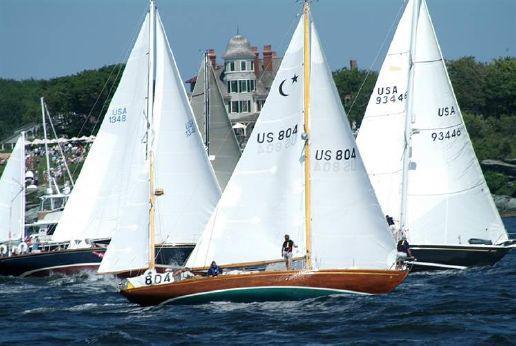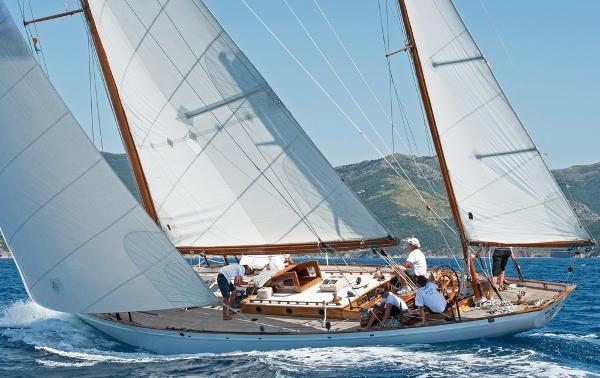The first image is the image on the left, the second image is the image on the right. Examine the images to the left and right. Is the description "The boat on the left doesn't have its sails up." accurate? Answer yes or no. No. 